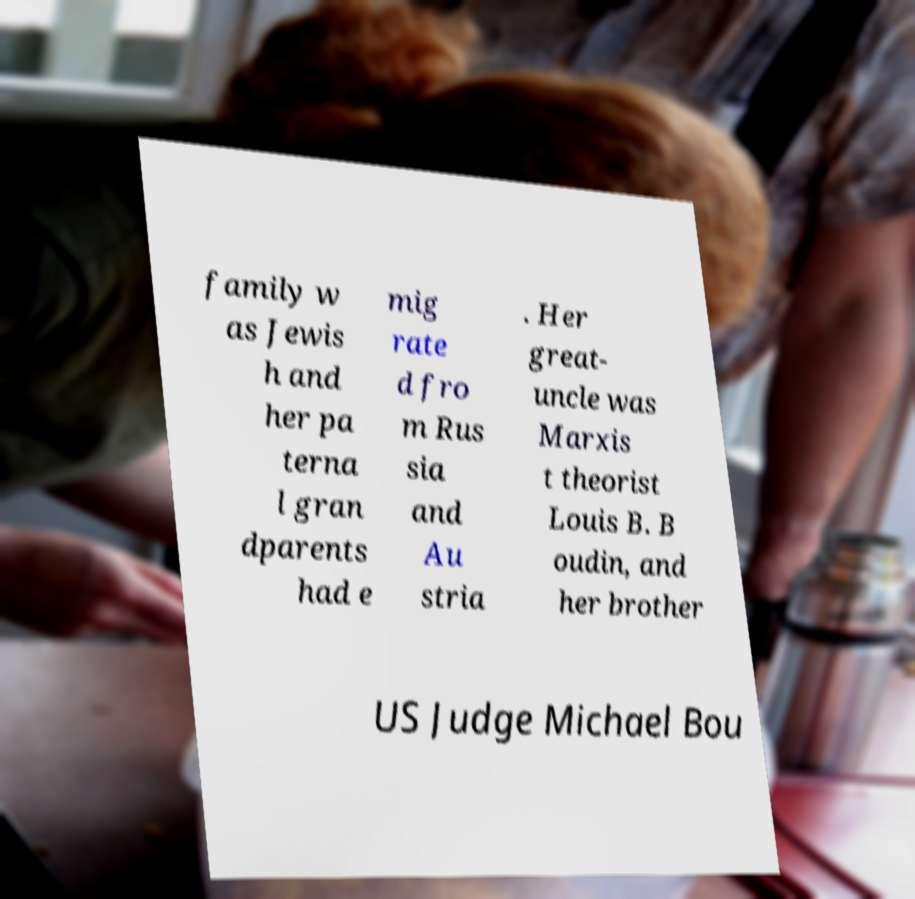For documentation purposes, I need the text within this image transcribed. Could you provide that? family w as Jewis h and her pa terna l gran dparents had e mig rate d fro m Rus sia and Au stria . Her great- uncle was Marxis t theorist Louis B. B oudin, and her brother US Judge Michael Bou 